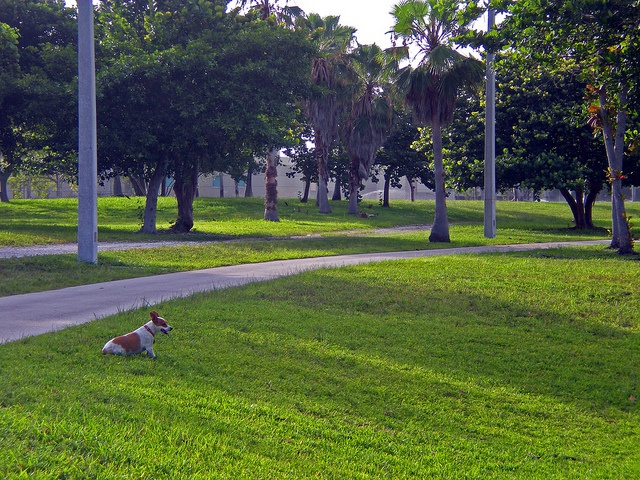Describe the objects in this image and their specific colors. I can see dog in gray, darkgreen, and purple tones and dog in gray, black, and purple tones in this image. 